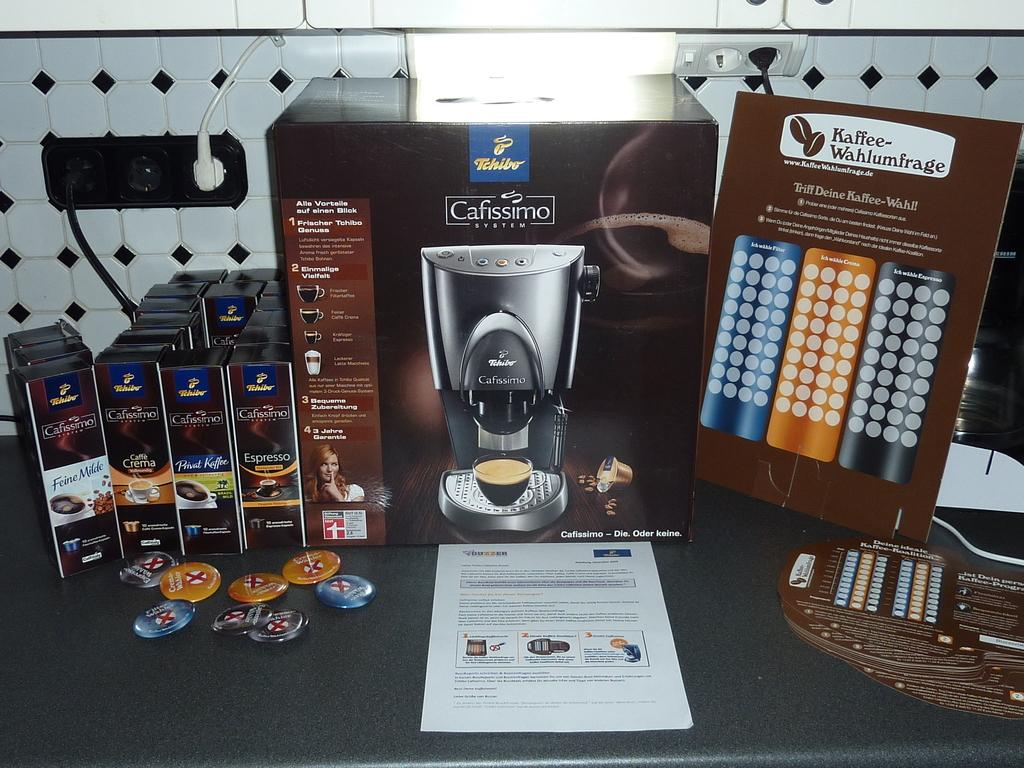<image>
Give a short and clear explanation of the subsequent image. A caffismo coffee machine is on display with all its components. 